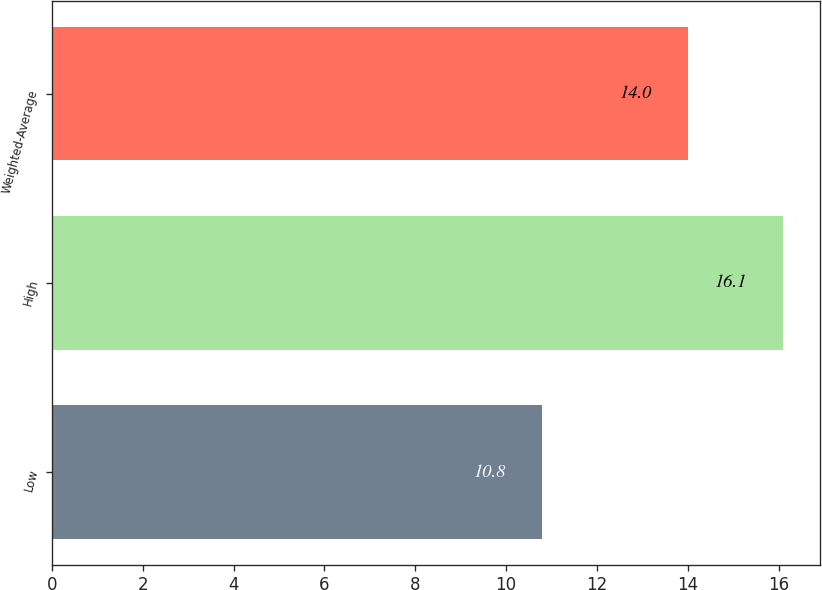Convert chart. <chart><loc_0><loc_0><loc_500><loc_500><bar_chart><fcel>Low<fcel>High<fcel>Weighted-Average<nl><fcel>10.8<fcel>16.1<fcel>14<nl></chart> 